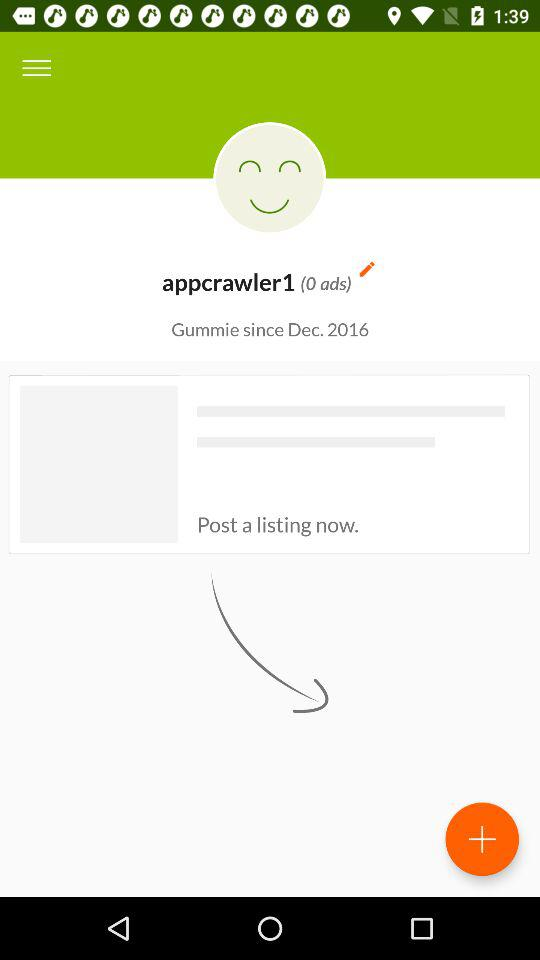What is the username? The username is "appcrawler1". 